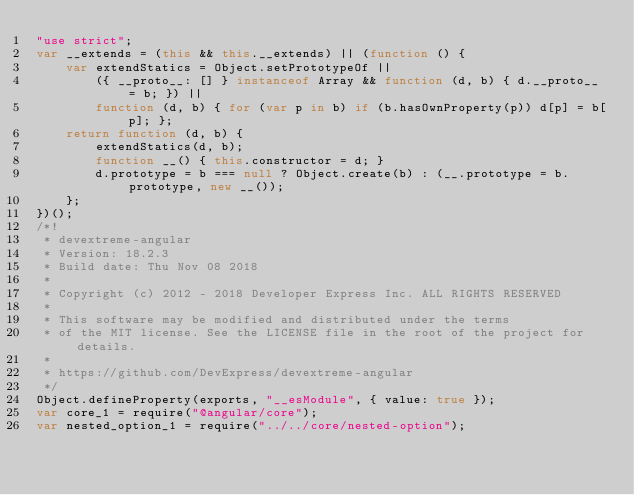<code> <loc_0><loc_0><loc_500><loc_500><_JavaScript_>"use strict";
var __extends = (this && this.__extends) || (function () {
    var extendStatics = Object.setPrototypeOf ||
        ({ __proto__: [] } instanceof Array && function (d, b) { d.__proto__ = b; }) ||
        function (d, b) { for (var p in b) if (b.hasOwnProperty(p)) d[p] = b[p]; };
    return function (d, b) {
        extendStatics(d, b);
        function __() { this.constructor = d; }
        d.prototype = b === null ? Object.create(b) : (__.prototype = b.prototype, new __());
    };
})();
/*!
 * devextreme-angular
 * Version: 18.2.3
 * Build date: Thu Nov 08 2018
 *
 * Copyright (c) 2012 - 2018 Developer Express Inc. ALL RIGHTS RESERVED
 *
 * This software may be modified and distributed under the terms
 * of the MIT license. See the LICENSE file in the root of the project for details.
 *
 * https://github.com/DevExpress/devextreme-angular
 */
Object.defineProperty(exports, "__esModule", { value: true });
var core_1 = require("@angular/core");
var nested_option_1 = require("../../core/nested-option");</code> 